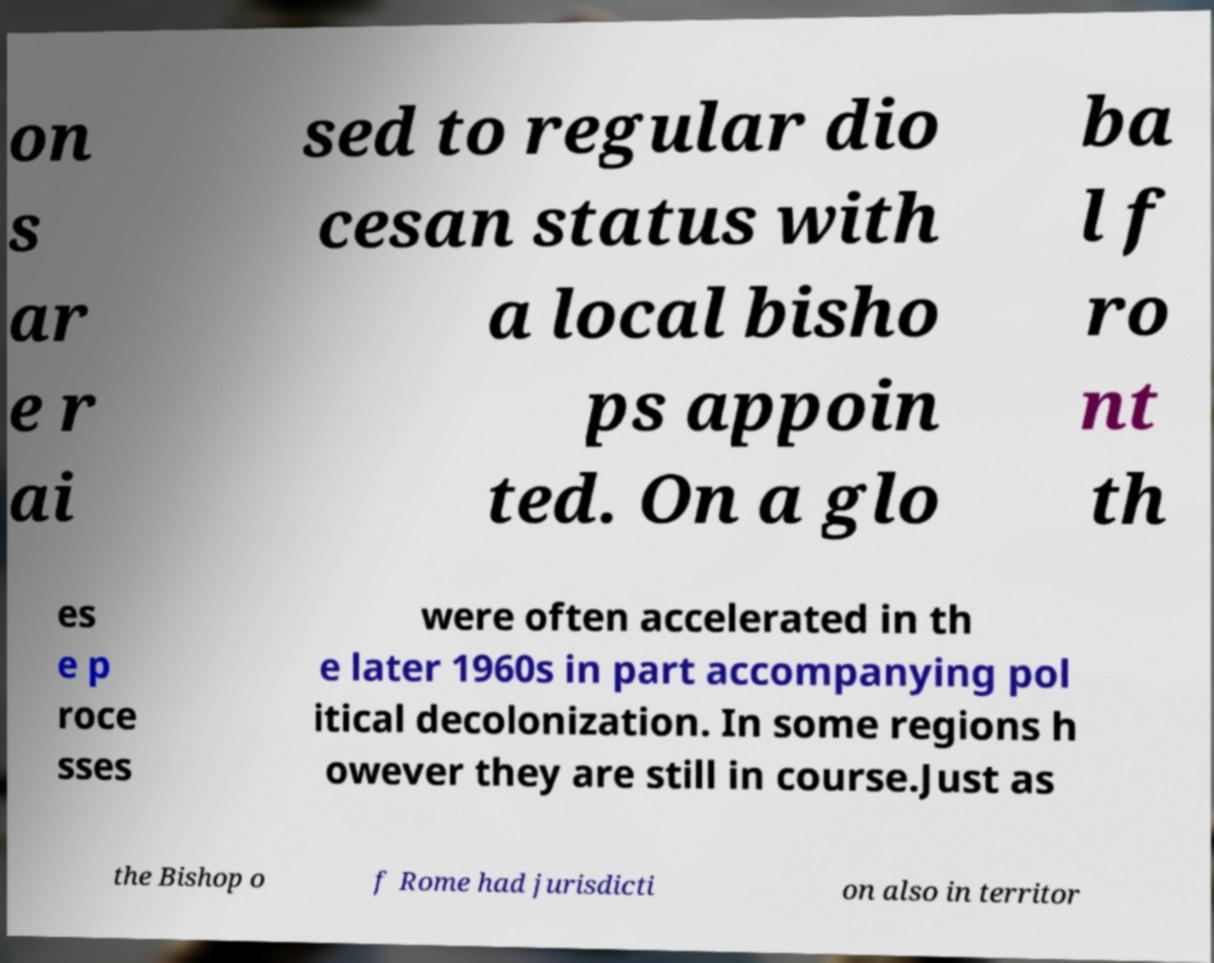Please read and relay the text visible in this image. What does it say? on s ar e r ai sed to regular dio cesan status with a local bisho ps appoin ted. On a glo ba l f ro nt th es e p roce sses were often accelerated in th e later 1960s in part accompanying pol itical decolonization. In some regions h owever they are still in course.Just as the Bishop o f Rome had jurisdicti on also in territor 